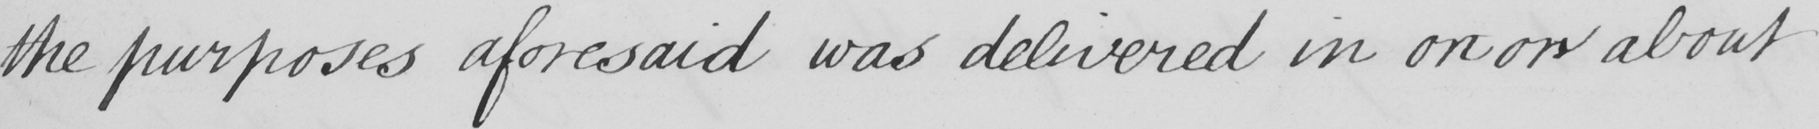What does this handwritten line say? the purposes aforesaid was delivered in on or about 